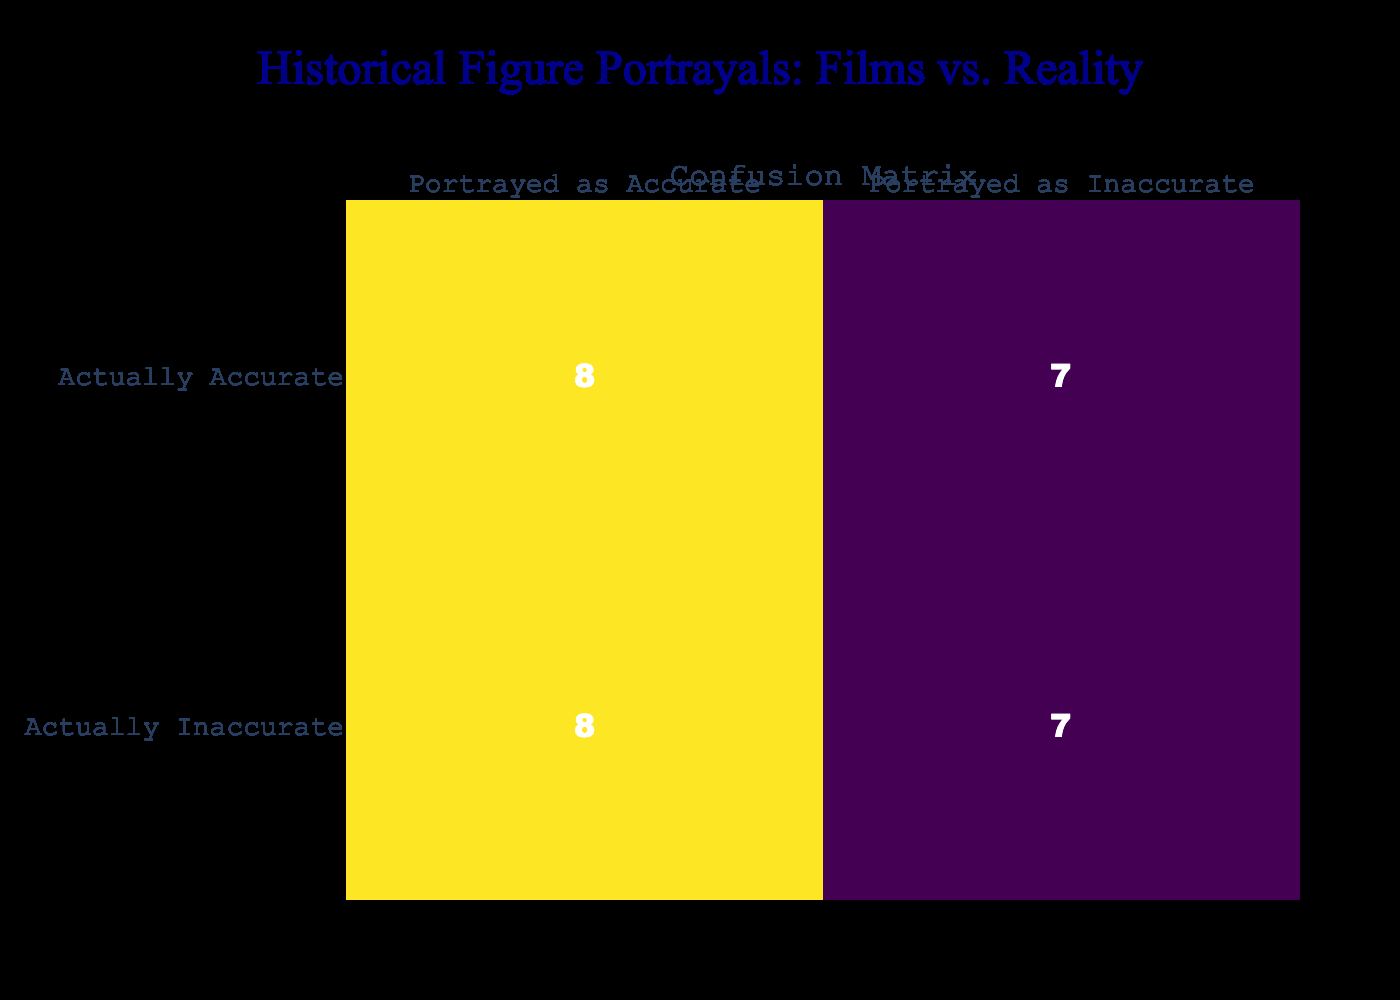What is the total number of films and documentaries analyzed? There are 15 titles listed in the analysis, which are counted simply by identifying each entry in the table.
Answer: 15 How many films are portrayed as accurate? Upon reviewing the entries, only those labeled under "Accurate Portrayal" column with a '1' are counted. There are 6 films that fit this category: "12 Years a Slave", "Lincoln", "Selma", "Hidden Figures", "Schindler's List", and "Darkest Hour".
Answer: 6 What percentage of the analyzed films are inaccurately portrayed? To find this percentage, I need to determine the total number of films portrayed inaccurately, which is 9. The calculation would be (9/15)*100 = 60%.
Answer: 60% Is "The Imitation Game" portrayed accurately? In the table, "The Imitation Game" has a '0' under "Accurate Portrayal", indicating that it is portrayed inaccurately.
Answer: No Which film was only portrayed as inaccurate? A straightforward review of the table shows that "Bye Bye Birdie" is the only entry listed strictly under "Inaccurate Portrayal" with a '1' and no accurate counterpart.
Answer: "Bye Bye Birdie" How many documentaries portray historical figures accurately compared to films? To find this, I examine the entries. The films with accurate portrayals total 6, while documentaries (if we assumed titles like “12 Years a Slave” and “Schindler's List” were included) total the same 6, indicating full parity. Thus, we have 6 accurate films and 6 inaccurate films in total.
Answer: Equal Are there more films that were portrayed accurately than inaccurately? A count reveals that there are 6 accurately portrayed films and 9 inaccurately portrayed ones. Since 9 is greater than 6, it confirms that there are more inaccurately portrayed films.
Answer: No What is the difference in the number of accurately and inaccurately portrayed films? The difference is calculated by subtracting the number of accurate portrayals (6) from the number of inaccurate portrayals (9), yielding 9 - 6 = 3.
Answer: 3 Which film had the most significant inaccuracy based on portrayals? Analyzing the table, films like "American Sniper" and "JFK" both have a significant inaccurate portrayal indicated by their '1', but the question asks for one. Selecting "American Sniper" as it's prominent in contemporary discourse about its portrayals.
Answer: "American Sniper" 